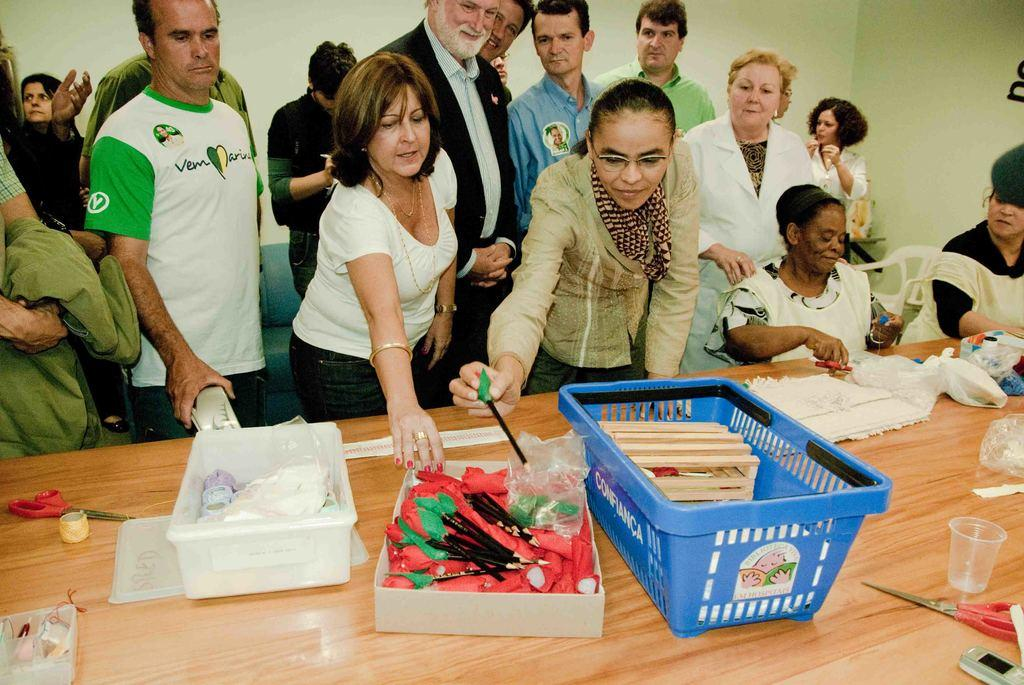What is on the table in the image? There is a basket, pens, scissors, and cups on the table in the image. Can you describe the other unspecified items on the table? Unfortunately, the facts do not specify what these other items are. How many people are visible in the background of the image? There are many people in the background of the image. What type of bear can be seen wearing a silver hat in the image? There is no bear or silver hat present in the image. 